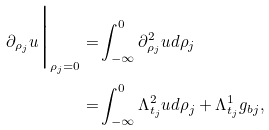Convert formula to latex. <formula><loc_0><loc_0><loc_500><loc_500>\partial _ { \rho _ { j } } u \Big | _ { \rho _ { j } = 0 } = & \int _ { - \infty } ^ { 0 } \partial _ { \rho _ { j } } ^ { 2 } u d \rho _ { j } \\ = & \int _ { - \infty } ^ { 0 } \Lambda _ { t _ { j } } ^ { 2 } u d \rho _ { j } + \Lambda _ { t _ { j } } ^ { 1 } g _ { b j } ,</formula> 